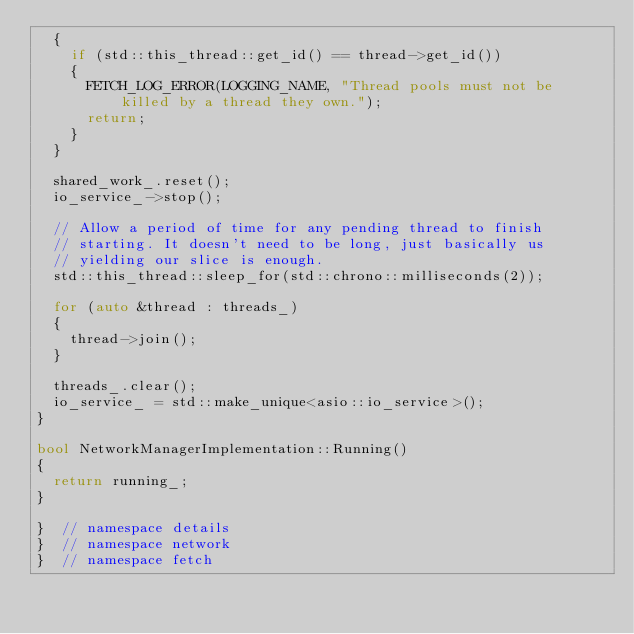Convert code to text. <code><loc_0><loc_0><loc_500><loc_500><_C++_>  {
    if (std::this_thread::get_id() == thread->get_id())
    {
      FETCH_LOG_ERROR(LOGGING_NAME, "Thread pools must not be killed by a thread they own.");
      return;
    }
  }

  shared_work_.reset();
  io_service_->stop();

  // Allow a period of time for any pending thread to finish
  // starting. It doesn't need to be long, just basically us
  // yielding our slice is enough.
  std::this_thread::sleep_for(std::chrono::milliseconds(2));

  for (auto &thread : threads_)
  {
    thread->join();
  }

  threads_.clear();
  io_service_ = std::make_unique<asio::io_service>();
}

bool NetworkManagerImplementation::Running()
{
  return running_;
}

}  // namespace details
}  // namespace network
}  // namespace fetch
</code> 